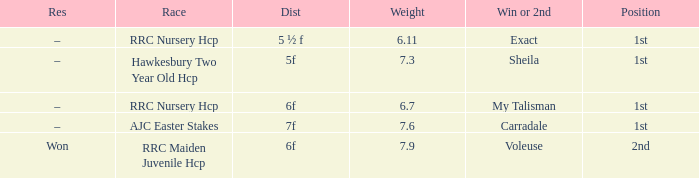What is the weight number when the distance was 5 ½ f? 1.0. 